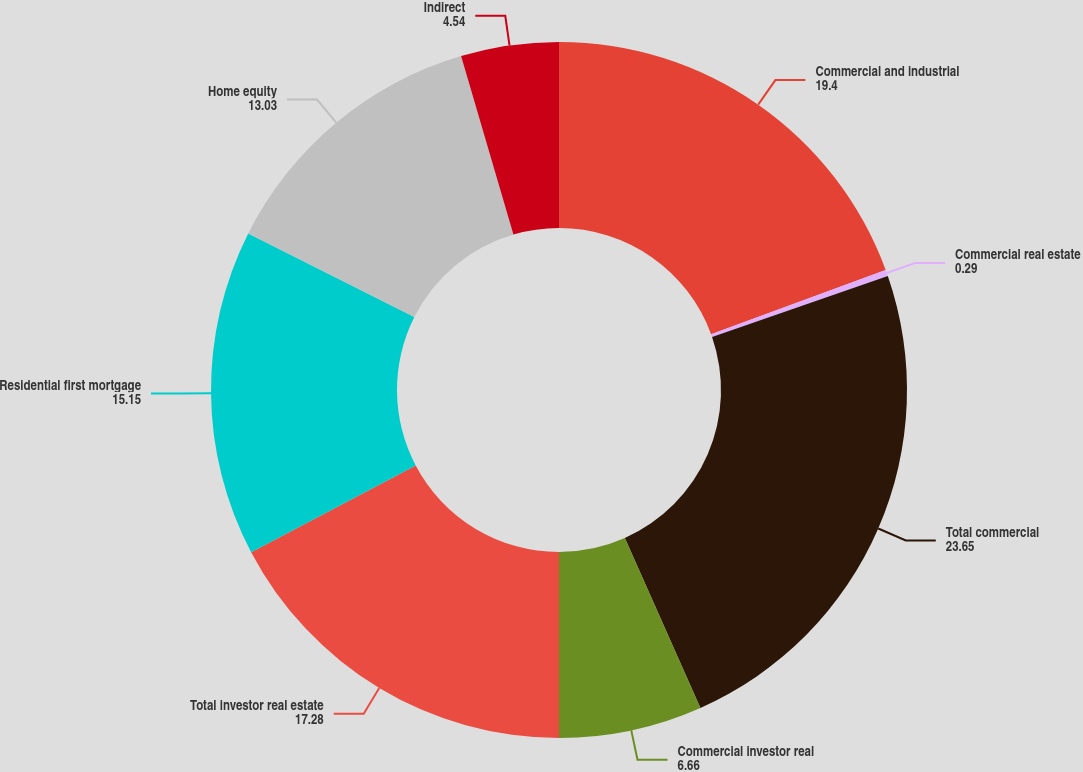Convert chart to OTSL. <chart><loc_0><loc_0><loc_500><loc_500><pie_chart><fcel>Commercial and industrial<fcel>Commercial real estate<fcel>Total commercial<fcel>Commercial investor real<fcel>Total investor real estate<fcel>Residential first mortgage<fcel>Home equity<fcel>Indirect<nl><fcel>19.4%<fcel>0.29%<fcel>23.65%<fcel>6.66%<fcel>17.28%<fcel>15.15%<fcel>13.03%<fcel>4.54%<nl></chart> 